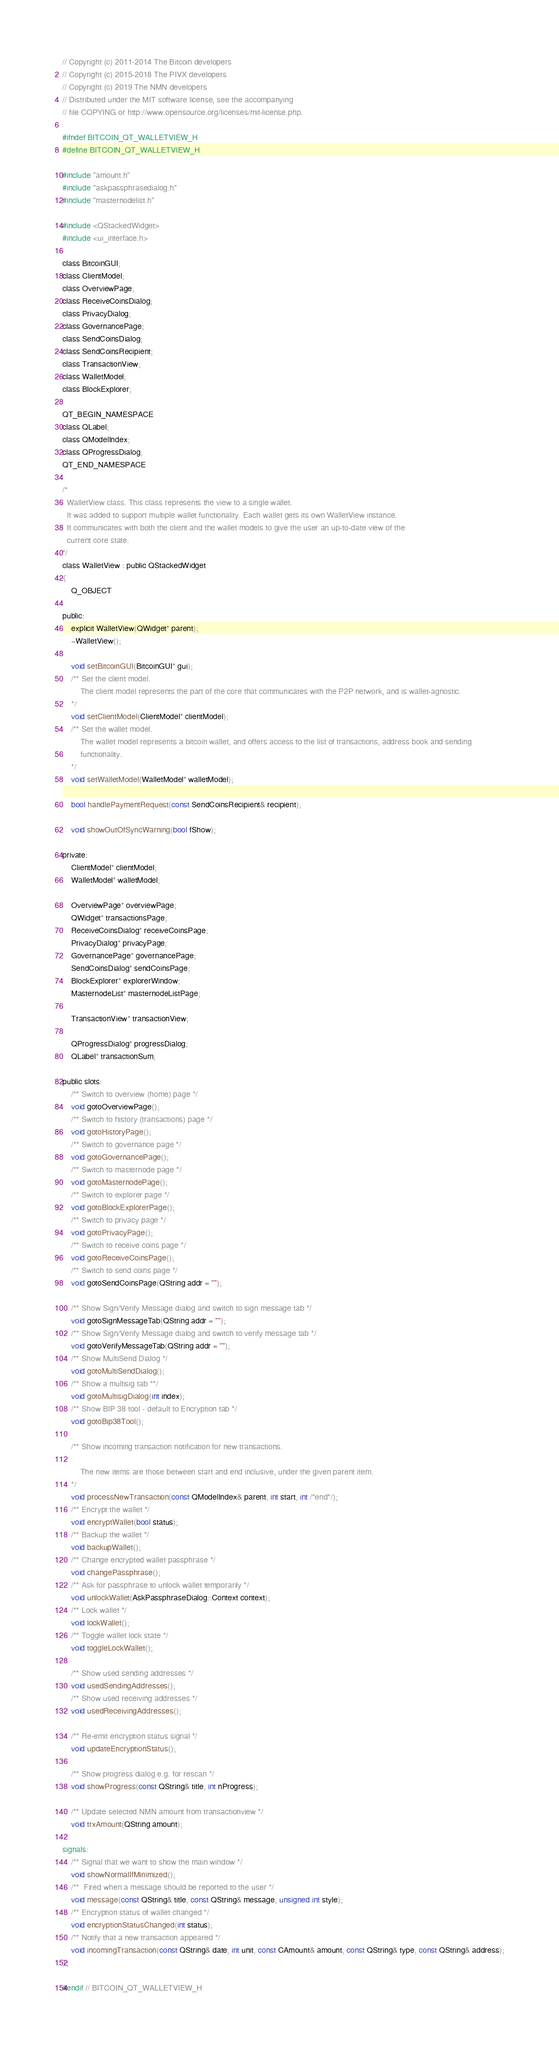<code> <loc_0><loc_0><loc_500><loc_500><_C_>// Copyright (c) 2011-2014 The Bitcoin developers
// Copyright (c) 2015-2018 The PIVX developers
// Copyright (c) 2019 The NMN developers
// Distributed under the MIT software license, see the accompanying
// file COPYING or http://www.opensource.org/licenses/mit-license.php.

#ifndef BITCOIN_QT_WALLETVIEW_H
#define BITCOIN_QT_WALLETVIEW_H

#include "amount.h"
#include "askpassphrasedialog.h"
#include "masternodelist.h"

#include <QStackedWidget>
#include <ui_interface.h>

class BitcoinGUI;
class ClientModel;
class OverviewPage;
class ReceiveCoinsDialog;
class PrivacyDialog;
class GovernancePage;
class SendCoinsDialog;
class SendCoinsRecipient;
class TransactionView;
class WalletModel;
class BlockExplorer;

QT_BEGIN_NAMESPACE
class QLabel;
class QModelIndex;
class QProgressDialog;
QT_END_NAMESPACE

/*
  WalletView class. This class represents the view to a single wallet.
  It was added to support multiple wallet functionality. Each wallet gets its own WalletView instance.
  It communicates with both the client and the wallet models to give the user an up-to-date view of the
  current core state.
*/
class WalletView : public QStackedWidget
{
    Q_OBJECT

public:
    explicit WalletView(QWidget* parent);
    ~WalletView();

    void setBitcoinGUI(BitcoinGUI* gui);
    /** Set the client model.
        The client model represents the part of the core that communicates with the P2P network, and is wallet-agnostic.
    */
    void setClientModel(ClientModel* clientModel);
    /** Set the wallet model.
        The wallet model represents a bitcoin wallet, and offers access to the list of transactions, address book and sending
        functionality.
    */
    void setWalletModel(WalletModel* walletModel);

    bool handlePaymentRequest(const SendCoinsRecipient& recipient);

    void showOutOfSyncWarning(bool fShow);

private:
    ClientModel* clientModel;
    WalletModel* walletModel;

    OverviewPage* overviewPage;
    QWidget* transactionsPage;
    ReceiveCoinsDialog* receiveCoinsPage;
    PrivacyDialog* privacyPage;
    GovernancePage* governancePage;
    SendCoinsDialog* sendCoinsPage;
    BlockExplorer* explorerWindow;
    MasternodeList* masternodeListPage;

    TransactionView* transactionView;

    QProgressDialog* progressDialog;
    QLabel* transactionSum;

public slots:
    /** Switch to overview (home) page */
    void gotoOverviewPage();
    /** Switch to history (transactions) page */
    void gotoHistoryPage();
    /** Switch to governance page */
    void gotoGovernancePage();
    /** Switch to masternode page */
    void gotoMasternodePage();
    /** Switch to explorer page */
    void gotoBlockExplorerPage();
    /** Switch to privacy page */
    void gotoPrivacyPage();
    /** Switch to receive coins page */
    void gotoReceiveCoinsPage();
    /** Switch to send coins page */
    void gotoSendCoinsPage(QString addr = "");

    /** Show Sign/Verify Message dialog and switch to sign message tab */
    void gotoSignMessageTab(QString addr = "");
    /** Show Sign/Verify Message dialog and switch to verify message tab */
    void gotoVerifyMessageTab(QString addr = "");
    /** Show MultiSend Dialog */
    void gotoMultiSendDialog();
    /** Show a multisig tab **/
    void gotoMultisigDialog(int index);
    /** Show BIP 38 tool - default to Encryption tab */
    void gotoBip38Tool();

    /** Show incoming transaction notification for new transactions.

        The new items are those between start and end inclusive, under the given parent item.
    */
    void processNewTransaction(const QModelIndex& parent, int start, int /*end*/);
    /** Encrypt the wallet */
    void encryptWallet(bool status);
    /** Backup the wallet */
    void backupWallet();
    /** Change encrypted wallet passphrase */
    void changePassphrase();
    /** Ask for passphrase to unlock wallet temporarily */
    void unlockWallet(AskPassphraseDialog::Context context);
    /** Lock wallet */
    void lockWallet();
    /** Toggle wallet lock state */
    void toggleLockWallet();

    /** Show used sending addresses */
    void usedSendingAddresses();
    /** Show used receiving addresses */
    void usedReceivingAddresses();

    /** Re-emit encryption status signal */
    void updateEncryptionStatus();

    /** Show progress dialog e.g. for rescan */
    void showProgress(const QString& title, int nProgress);

    /** Update selected NMN amount from transactionview */
    void trxAmount(QString amount);

signals:
    /** Signal that we want to show the main window */
    void showNormalIfMinimized();
    /**  Fired when a message should be reported to the user */
    void message(const QString& title, const QString& message, unsigned int style);
    /** Encryption status of wallet changed */
    void encryptionStatusChanged(int status);
    /** Notify that a new transaction appeared */
    void incomingTransaction(const QString& date, int unit, const CAmount& amount, const QString& type, const QString& address);
};

#endif // BITCOIN_QT_WALLETVIEW_H
</code> 